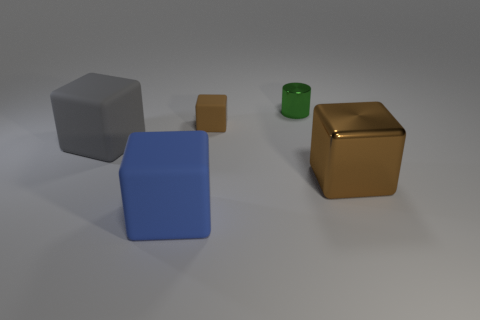Is there any other thing that is the same material as the tiny brown cube?
Provide a succinct answer. Yes. There is a shiny cube; is it the same color as the tiny thing that is on the left side of the small cylinder?
Ensure brevity in your answer.  Yes. Are there any big matte blocks that are behind the brown object behind the brown object that is right of the green object?
Keep it short and to the point. No. Is the number of large cubes that are to the right of the brown matte thing less than the number of tiny cubes?
Give a very brief answer. No. What number of other things are the same shape as the brown metal thing?
Offer a very short reply. 3. What number of things are either large rubber things that are behind the blue block or things that are to the right of the gray rubber block?
Your response must be concise. 5. There is a thing that is right of the blue rubber thing and on the left side of the green cylinder; how big is it?
Keep it short and to the point. Small. There is a thing that is on the left side of the blue block; is it the same shape as the large brown metal thing?
Your answer should be very brief. Yes. There is a block that is left of the matte cube in front of the matte object that is on the left side of the large blue object; what size is it?
Make the answer very short. Large. What is the size of the thing that is the same color as the metal cube?
Your answer should be compact. Small. 